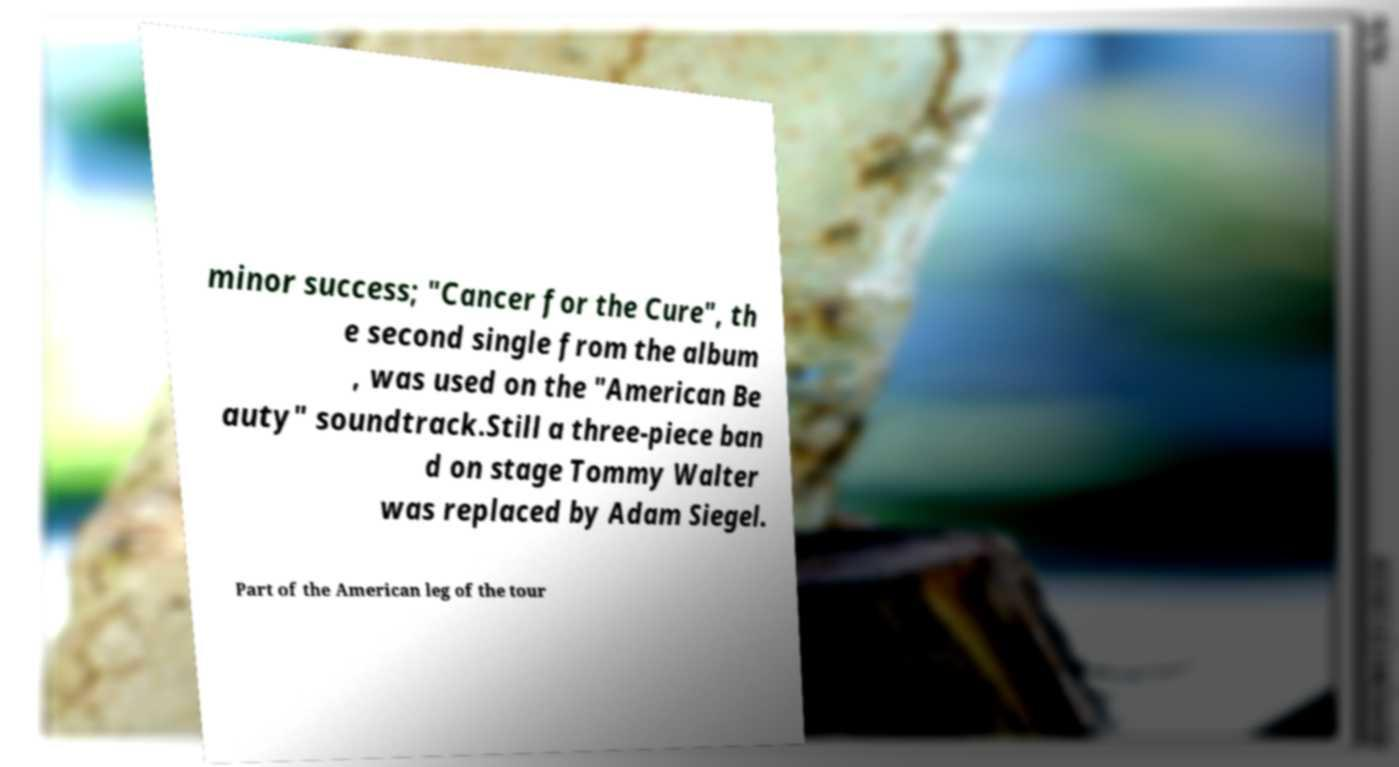Could you extract and type out the text from this image? minor success; "Cancer for the Cure", th e second single from the album , was used on the "American Be auty" soundtrack.Still a three-piece ban d on stage Tommy Walter was replaced by Adam Siegel. Part of the American leg of the tour 